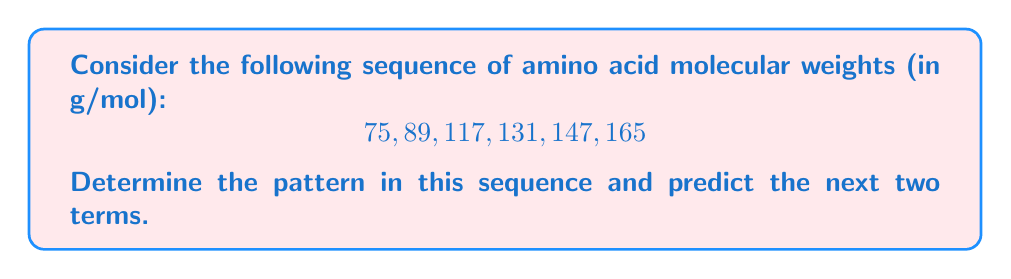Could you help me with this problem? To solve this problem, let's approach it step-by-step:

1. First, let's calculate the differences between consecutive terms:
   $89 - 75 = 14$
   $117 - 89 = 28$
   $131 - 117 = 14$
   $147 - 131 = 16$
   $165 - 147 = 18$

2. We can observe that the differences alternate between adding 14 and adding a number that increases by 2 each time:
   14, 28 (+14), 14, 16 (+2), 18 (+2)

3. This pattern suggests that the sequence is formed by alternating between:
   a) Adding 14
   b) Adding a number that starts at 28 and increases by 2 each time it's used

4. To predict the next term, we would add 14 to the last term:
   $165 + 14 = 179$

5. For the term after that, we would add the next number in the increasing sequence (20):
   $179 + 20 = 199$

This pattern is consistent with the molecular weight differences between some common amino acids. For example, the difference of 14 g/mol could represent the addition of a CH2 group, which is a common modification in amino acid side chains.
Answer: 179, 199 